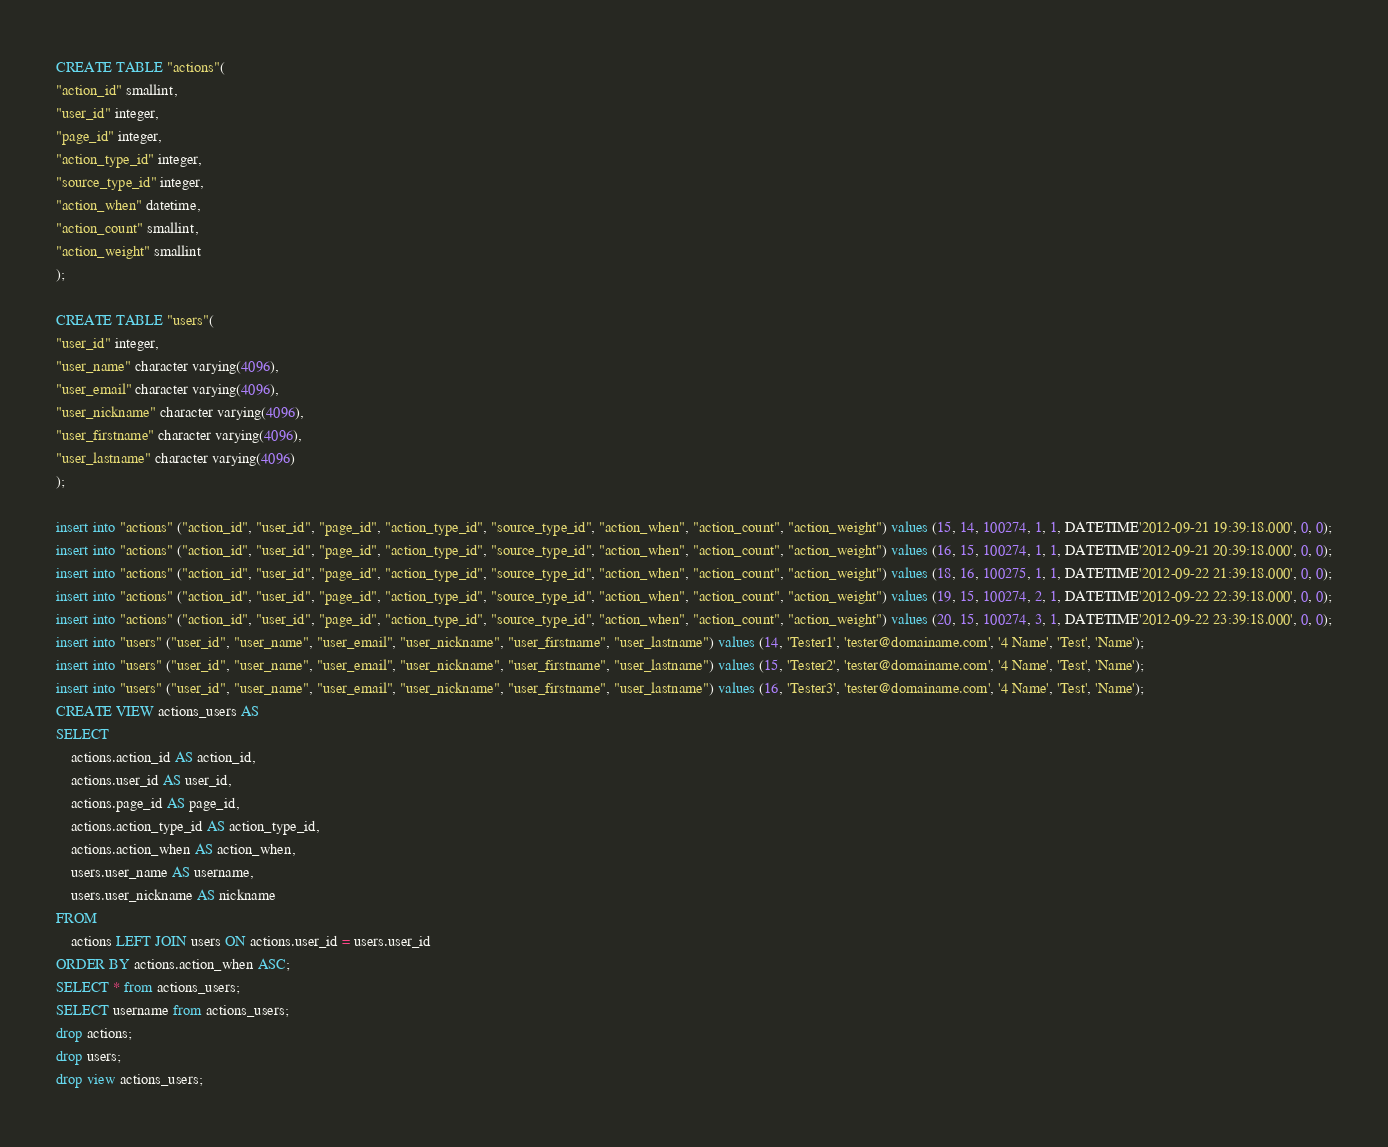Convert code to text. <code><loc_0><loc_0><loc_500><loc_500><_SQL_>CREATE TABLE "actions"(
"action_id" smallint,
"user_id" integer,
"page_id" integer,
"action_type_id" integer,
"source_type_id" integer,
"action_when" datetime,
"action_count" smallint,
"action_weight" smallint
);

CREATE TABLE "users"(
"user_id" integer,
"user_name" character varying(4096),
"user_email" character varying(4096),
"user_nickname" character varying(4096),
"user_firstname" character varying(4096),
"user_lastname" character varying(4096)
);

insert into "actions" ("action_id", "user_id", "page_id", "action_type_id", "source_type_id", "action_when", "action_count", "action_weight") values (15, 14, 100274, 1, 1, DATETIME'2012-09-21 19:39:18.000', 0, 0);
insert into "actions" ("action_id", "user_id", "page_id", "action_type_id", "source_type_id", "action_when", "action_count", "action_weight") values (16, 15, 100274, 1, 1, DATETIME'2012-09-21 20:39:18.000', 0, 0);
insert into "actions" ("action_id", "user_id", "page_id", "action_type_id", "source_type_id", "action_when", "action_count", "action_weight") values (18, 16, 100275, 1, 1, DATETIME'2012-09-22 21:39:18.000', 0, 0);
insert into "actions" ("action_id", "user_id", "page_id", "action_type_id", "source_type_id", "action_when", "action_count", "action_weight") values (19, 15, 100274, 2, 1, DATETIME'2012-09-22 22:39:18.000', 0, 0);
insert into "actions" ("action_id", "user_id", "page_id", "action_type_id", "source_type_id", "action_when", "action_count", "action_weight") values (20, 15, 100274, 3, 1, DATETIME'2012-09-22 23:39:18.000', 0, 0);
insert into "users" ("user_id", "user_name", "user_email", "user_nickname", "user_firstname", "user_lastname") values (14, 'Tester1', 'tester@domainame.com', '4 Name', 'Test', 'Name');
insert into "users" ("user_id", "user_name", "user_email", "user_nickname", "user_firstname", "user_lastname") values (15, 'Tester2', 'tester@domainame.com', '4 Name', 'Test', 'Name');
insert into "users" ("user_id", "user_name", "user_email", "user_nickname", "user_firstname", "user_lastname") values (16, 'Tester3', 'tester@domainame.com', '4 Name', 'Test', 'Name');
CREATE VIEW actions_users AS
SELECT
    actions.action_id AS action_id,
    actions.user_id AS user_id,
    actions.page_id AS page_id,
    actions.action_type_id AS action_type_id,
    actions.action_when AS action_when,
    users.user_name AS username,
    users.user_nickname AS nickname
FROM
    actions LEFT JOIN users ON actions.user_id = users.user_id
ORDER BY actions.action_when ASC;
SELECT * from actions_users;
SELECT username from actions_users;
drop actions;
drop users;
drop view actions_users;
</code> 